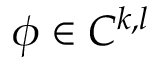Convert formula to latex. <formula><loc_0><loc_0><loc_500><loc_500>\phi \in C ^ { k , l }</formula> 